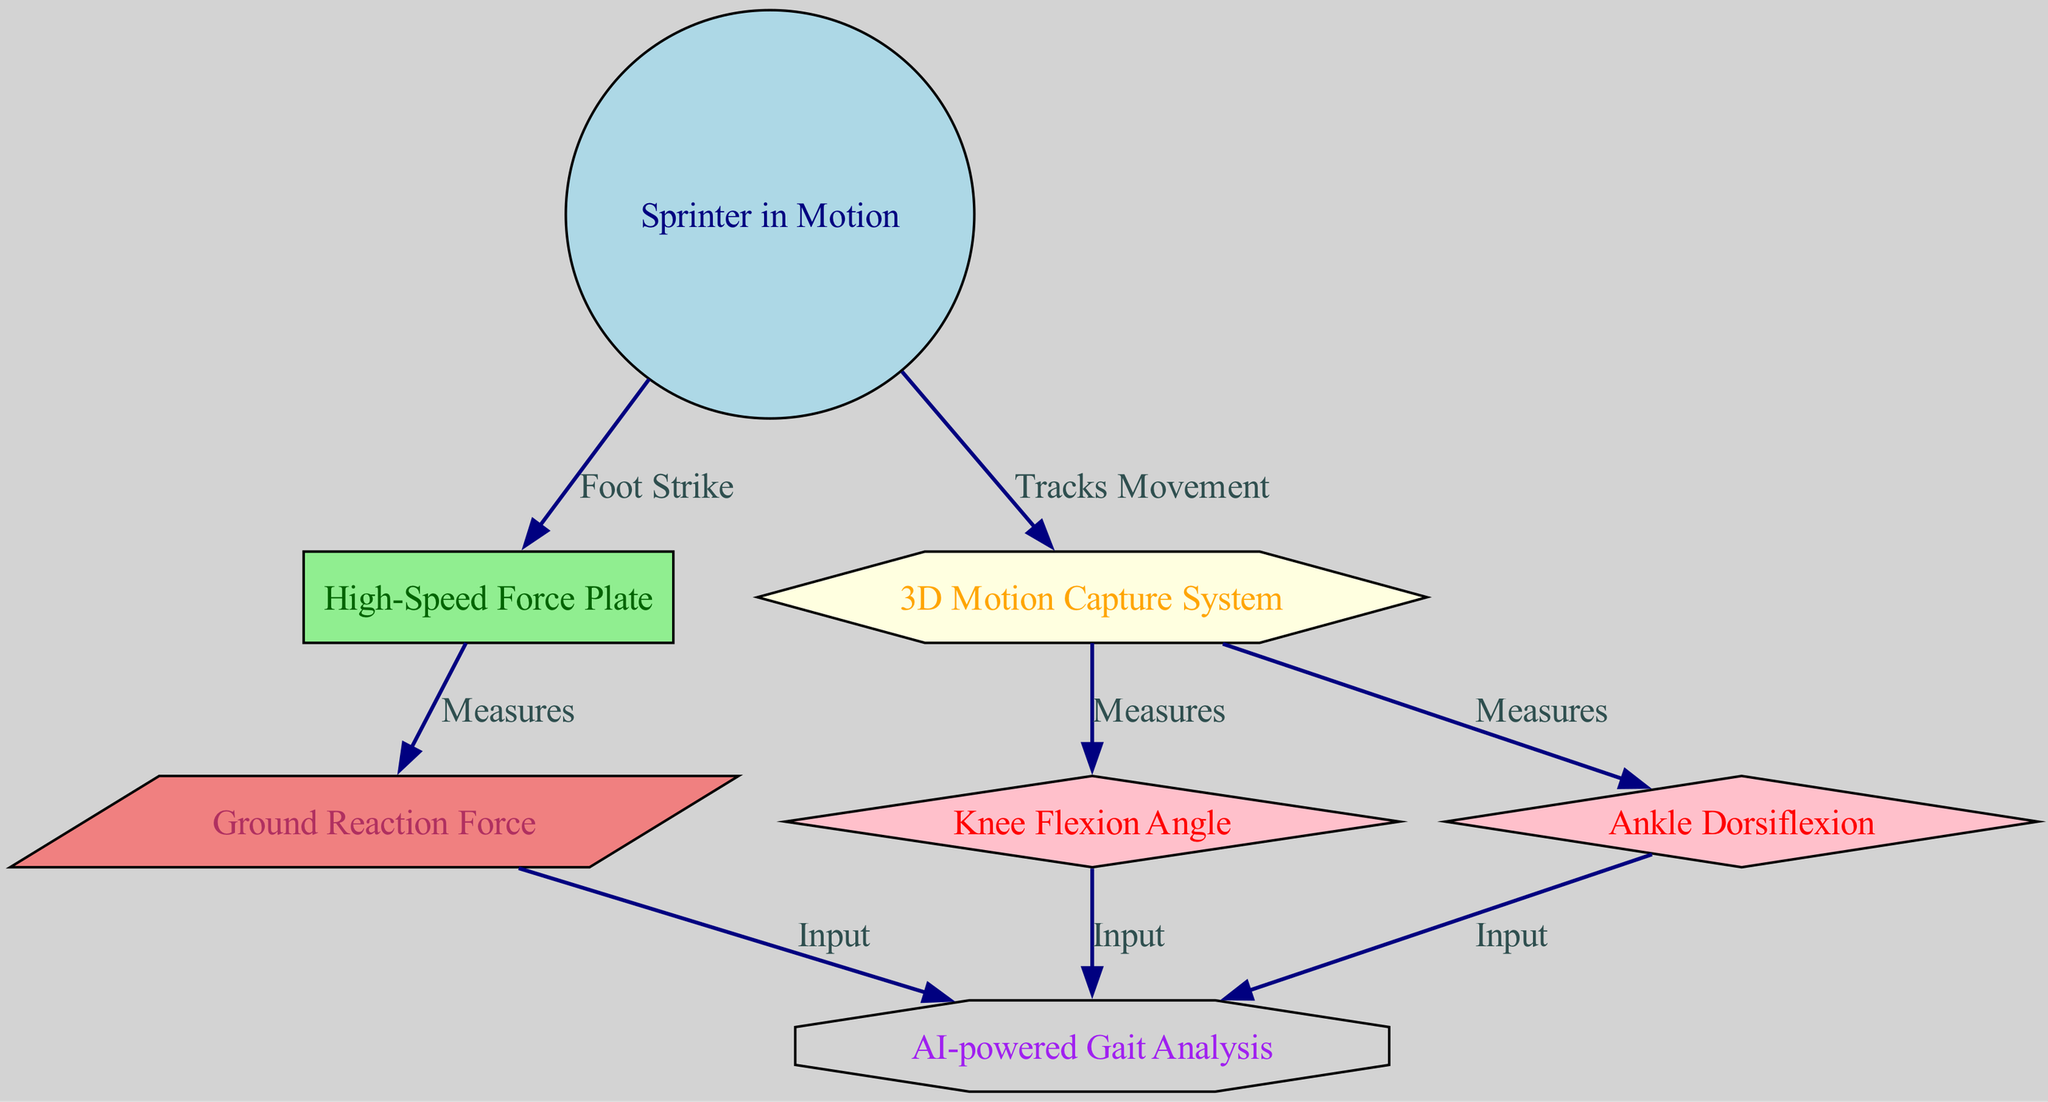What is the total number of nodes in the diagram? The diagram contains nodes for "Sprinter in Motion," "High-Speed Force Plate," "3D Motion Capture System," "Knee Flexion Angle," "Ankle Dorsiflexion," "Ground Reaction Force," and "AI-powered Gait Analysis." Counting these gives a total of 7 nodes.
Answer: 7 What relationship does the "Sprinter in Motion" have with the "High-Speed Force Plate"? The "Sprinter in Motion" has a directed relationship labeled "Foot Strike" that connects it to the "High-Speed Force Plate," indicating the point of interaction where the athlete's foot strikes the plate.
Answer: Foot Strike How many edges are present in the diagram? The diagram has edges that represent relationships among the nodes. There are a total of 8 edges connecting these nodes, based on the given connectivity.
Answer: 8 What type of system measures the "Knee Flexion Angle"? The "3D Motion Capture System" is responsible for measuring the "Knee Flexion Angle," as indicated by the direct relationship from the motion capture node to the knee angle node.
Answer: 3D Motion Capture System What inputs does the "AI-powered Gait Analysis" receive? The "AI-powered Gait Analysis" node receives inputs from "Ground Reaction Force," "Knee Flexion Angle," and "Ankle Dorsiflexion," which are all directed towards it as inputs. Therefore, these three measurements are essential for analysis.
Answer: Ground Reaction Force, Knee Flexion Angle, Ankle Dorsiflexion How does the "High-Speed Force Plate" relate to the "Ground Reaction Force"? The "High-Speed Force Plate" measures the "Ground Reaction Force," establishing a direct and unidirectional relationship from the force plate to the ground reaction force, indicating its role in quantifying force during athlete's foot strike.
Answer: Measures What shape represents the "AI-powered Gait Analysis" in the diagram? The "AI-powered Gait Analysis" is represented by an octagon shape in the diagram, as indicated by the node styling described in the data structure.
Answer: Octagon Explain the flow of information from the "Athlete" to the "AI-powered Gait Analysis." The flow of information begins with the "Athlete," who strikes the "High-Speed Force Plate." The force plate measures the "Ground Reaction Force." Simultaneously, the "3D Motion Capture System" tracks the athlete's movement and measures the "Knee Flexion Angle" and "Ankle Dorsiflexion." All these measurements (ground reaction force, knee angle, and ankle angle) are then inputted into the "AI-powered Gait Analysis" for further analysis.
Answer: Athlete → High-Speed Force Plate → Ground Reaction Force; Athlete → 3D Motion Capture System → Knee Flexion Angle, Ankle Dorsiflexion → AI-powered Gait Analysis 